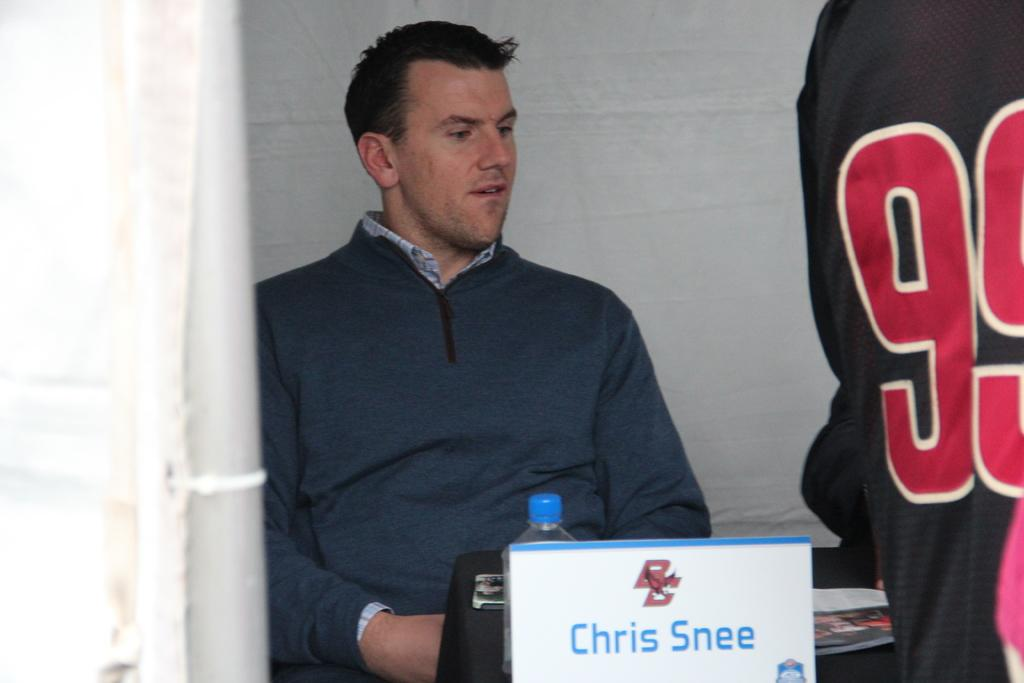Provide a one-sentence caption for the provided image. Man named Chris Snee sitting behind a table with a waterbottle. 